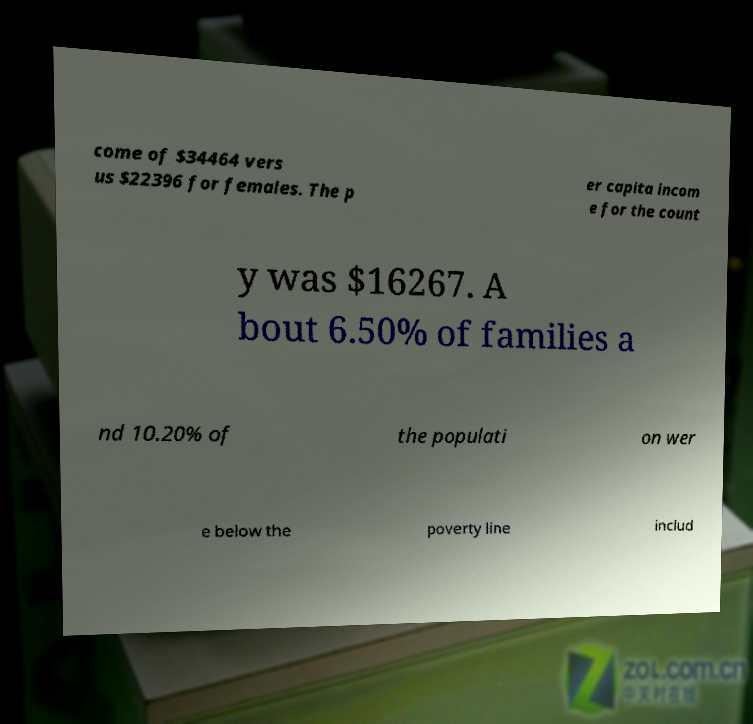Please identify and transcribe the text found in this image. come of $34464 vers us $22396 for females. The p er capita incom e for the count y was $16267. A bout 6.50% of families a nd 10.20% of the populati on wer e below the poverty line includ 